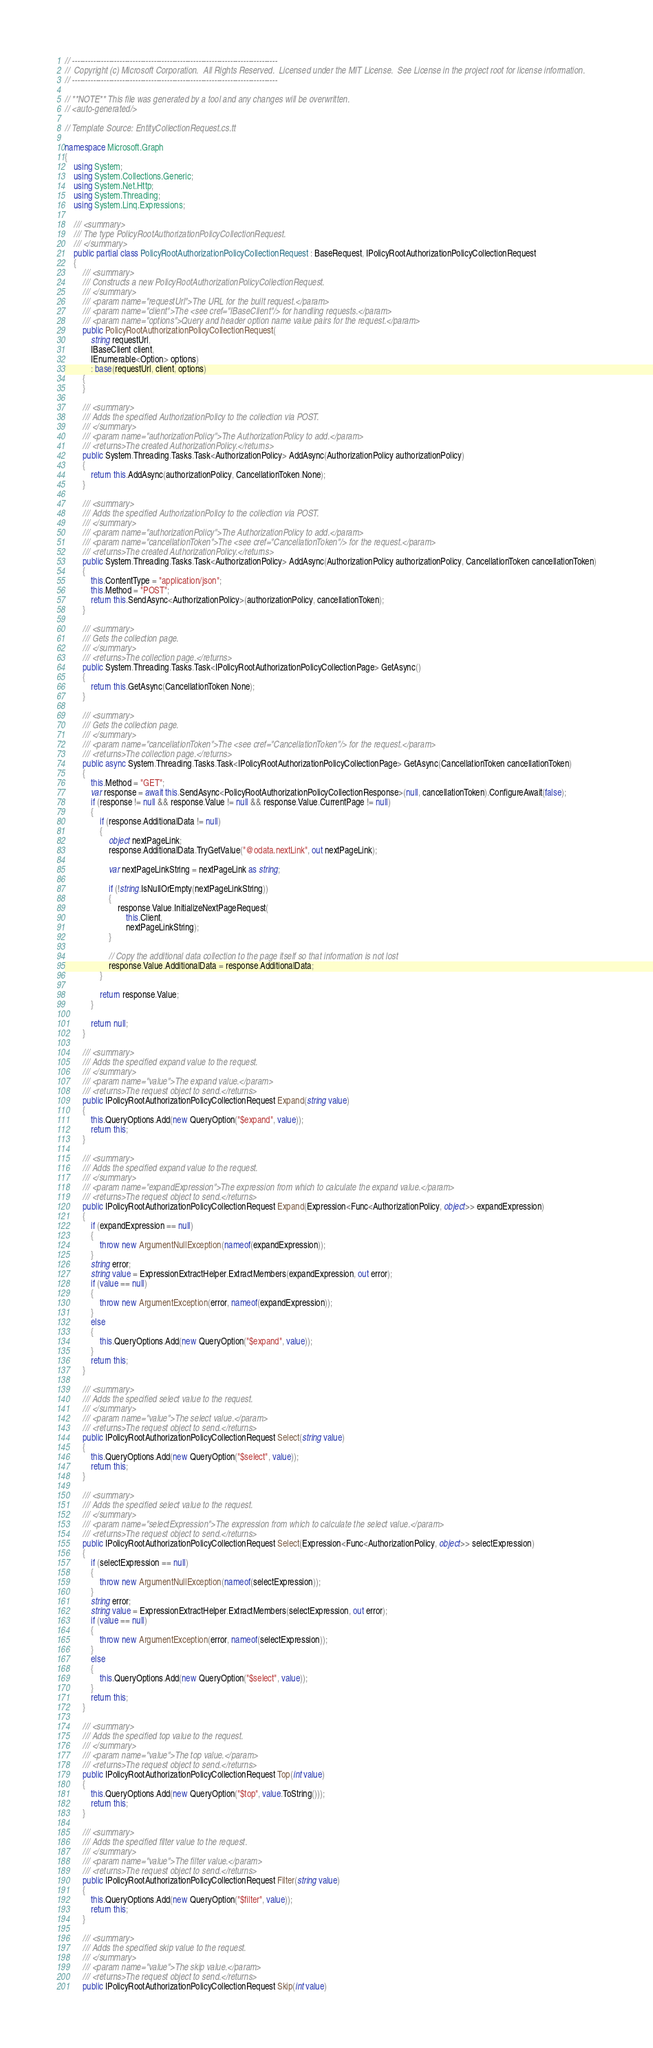Convert code to text. <code><loc_0><loc_0><loc_500><loc_500><_C#_>// ------------------------------------------------------------------------------
//  Copyright (c) Microsoft Corporation.  All Rights Reserved.  Licensed under the MIT License.  See License in the project root for license information.
// ------------------------------------------------------------------------------

// **NOTE** This file was generated by a tool and any changes will be overwritten.
// <auto-generated/>

// Template Source: EntityCollectionRequest.cs.tt

namespace Microsoft.Graph
{
    using System;
    using System.Collections.Generic;
    using System.Net.Http;
    using System.Threading;
    using System.Linq.Expressions;

    /// <summary>
    /// The type PolicyRootAuthorizationPolicyCollectionRequest.
    /// </summary>
    public partial class PolicyRootAuthorizationPolicyCollectionRequest : BaseRequest, IPolicyRootAuthorizationPolicyCollectionRequest
    {
        /// <summary>
        /// Constructs a new PolicyRootAuthorizationPolicyCollectionRequest.
        /// </summary>
        /// <param name="requestUrl">The URL for the built request.</param>
        /// <param name="client">The <see cref="IBaseClient"/> for handling requests.</param>
        /// <param name="options">Query and header option name value pairs for the request.</param>
        public PolicyRootAuthorizationPolicyCollectionRequest(
            string requestUrl,
            IBaseClient client,
            IEnumerable<Option> options)
            : base(requestUrl, client, options)
        {
        }
        
        /// <summary>
        /// Adds the specified AuthorizationPolicy to the collection via POST.
        /// </summary>
        /// <param name="authorizationPolicy">The AuthorizationPolicy to add.</param>
        /// <returns>The created AuthorizationPolicy.</returns>
        public System.Threading.Tasks.Task<AuthorizationPolicy> AddAsync(AuthorizationPolicy authorizationPolicy)
        {
            return this.AddAsync(authorizationPolicy, CancellationToken.None);
        }

        /// <summary>
        /// Adds the specified AuthorizationPolicy to the collection via POST.
        /// </summary>
        /// <param name="authorizationPolicy">The AuthorizationPolicy to add.</param>
        /// <param name="cancellationToken">The <see cref="CancellationToken"/> for the request.</param>
        /// <returns>The created AuthorizationPolicy.</returns>
        public System.Threading.Tasks.Task<AuthorizationPolicy> AddAsync(AuthorizationPolicy authorizationPolicy, CancellationToken cancellationToken)
        {
            this.ContentType = "application/json";
            this.Method = "POST";
            return this.SendAsync<AuthorizationPolicy>(authorizationPolicy, cancellationToken);
        }

        /// <summary>
        /// Gets the collection page.
        /// </summary>
        /// <returns>The collection page.</returns>
        public System.Threading.Tasks.Task<IPolicyRootAuthorizationPolicyCollectionPage> GetAsync()
        {
            return this.GetAsync(CancellationToken.None);
        }

        /// <summary>
        /// Gets the collection page.
        /// </summary>
        /// <param name="cancellationToken">The <see cref="CancellationToken"/> for the request.</param>
        /// <returns>The collection page.</returns>
        public async System.Threading.Tasks.Task<IPolicyRootAuthorizationPolicyCollectionPage> GetAsync(CancellationToken cancellationToken)
        {
            this.Method = "GET";
            var response = await this.SendAsync<PolicyRootAuthorizationPolicyCollectionResponse>(null, cancellationToken).ConfigureAwait(false);
            if (response != null && response.Value != null && response.Value.CurrentPage != null)
            {
                if (response.AdditionalData != null)
                {
                    object nextPageLink;
                    response.AdditionalData.TryGetValue("@odata.nextLink", out nextPageLink);

                    var nextPageLinkString = nextPageLink as string;

                    if (!string.IsNullOrEmpty(nextPageLinkString))
                    {
                        response.Value.InitializeNextPageRequest(
                            this.Client,
                            nextPageLinkString);
                    }

                    // Copy the additional data collection to the page itself so that information is not lost
                    response.Value.AdditionalData = response.AdditionalData;
                }

                return response.Value;
            }

            return null;
        }

        /// <summary>
        /// Adds the specified expand value to the request.
        /// </summary>
        /// <param name="value">The expand value.</param>
        /// <returns>The request object to send.</returns>
        public IPolicyRootAuthorizationPolicyCollectionRequest Expand(string value)
        {
            this.QueryOptions.Add(new QueryOption("$expand", value));
            return this;
        }

        /// <summary>
        /// Adds the specified expand value to the request.
        /// </summary>
        /// <param name="expandExpression">The expression from which to calculate the expand value.</param>
        /// <returns>The request object to send.</returns>
        public IPolicyRootAuthorizationPolicyCollectionRequest Expand(Expression<Func<AuthorizationPolicy, object>> expandExpression)
        {
            if (expandExpression == null)
            {
                throw new ArgumentNullException(nameof(expandExpression));
            }
            string error;
            string value = ExpressionExtractHelper.ExtractMembers(expandExpression, out error);
            if (value == null)
            {
                throw new ArgumentException(error, nameof(expandExpression));
            }
            else
            {
                this.QueryOptions.Add(new QueryOption("$expand", value));
            }
            return this;
        }

        /// <summary>
        /// Adds the specified select value to the request.
        /// </summary>
        /// <param name="value">The select value.</param>
        /// <returns>The request object to send.</returns>
        public IPolicyRootAuthorizationPolicyCollectionRequest Select(string value)
        {
            this.QueryOptions.Add(new QueryOption("$select", value));
            return this;
        }

        /// <summary>
        /// Adds the specified select value to the request.
        /// </summary>
        /// <param name="selectExpression">The expression from which to calculate the select value.</param>
        /// <returns>The request object to send.</returns>
        public IPolicyRootAuthorizationPolicyCollectionRequest Select(Expression<Func<AuthorizationPolicy, object>> selectExpression)
        {
            if (selectExpression == null)
            {
                throw new ArgumentNullException(nameof(selectExpression));
            }
            string error;
            string value = ExpressionExtractHelper.ExtractMembers(selectExpression, out error);
            if (value == null)
            {
                throw new ArgumentException(error, nameof(selectExpression));
            }
            else
            {
                this.QueryOptions.Add(new QueryOption("$select", value));
            }
            return this;
        }

        /// <summary>
        /// Adds the specified top value to the request.
        /// </summary>
        /// <param name="value">The top value.</param>
        /// <returns>The request object to send.</returns>
        public IPolicyRootAuthorizationPolicyCollectionRequest Top(int value)
        {
            this.QueryOptions.Add(new QueryOption("$top", value.ToString()));
            return this;
        }

        /// <summary>
        /// Adds the specified filter value to the request.
        /// </summary>
        /// <param name="value">The filter value.</param>
        /// <returns>The request object to send.</returns>
        public IPolicyRootAuthorizationPolicyCollectionRequest Filter(string value)
        {
            this.QueryOptions.Add(new QueryOption("$filter", value));
            return this;
        }

        /// <summary>
        /// Adds the specified skip value to the request.
        /// </summary>
        /// <param name="value">The skip value.</param>
        /// <returns>The request object to send.</returns>
        public IPolicyRootAuthorizationPolicyCollectionRequest Skip(int value)</code> 